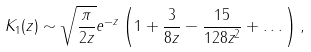<formula> <loc_0><loc_0><loc_500><loc_500>K _ { 1 } ( z ) \sim \sqrt { \frac { \pi } { 2 z } } e ^ { - z } \left ( 1 + \frac { 3 } { 8 z } - \frac { 1 5 } { 1 2 8 z ^ { 2 } } + \dots \right ) ,</formula> 